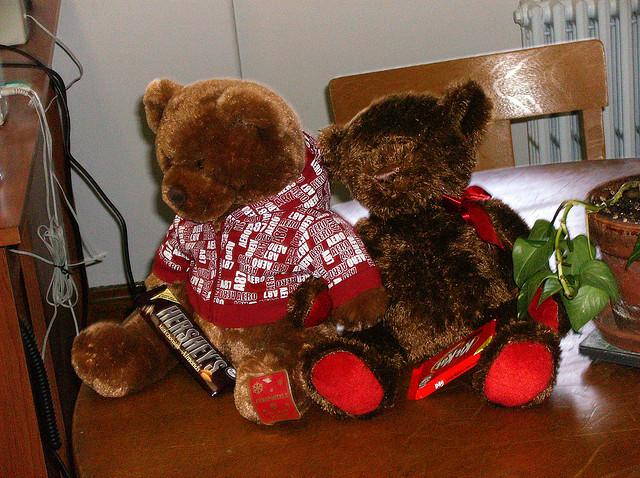What kind of candy bar is hanging on the leg of the teddy with a hoodie sweater put on? hersheys 